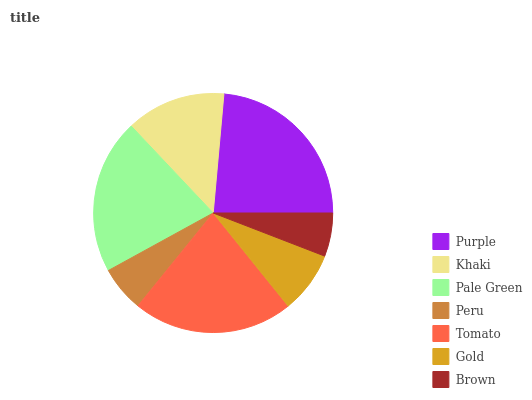Is Brown the minimum?
Answer yes or no. Yes. Is Purple the maximum?
Answer yes or no. Yes. Is Khaki the minimum?
Answer yes or no. No. Is Khaki the maximum?
Answer yes or no. No. Is Purple greater than Khaki?
Answer yes or no. Yes. Is Khaki less than Purple?
Answer yes or no. Yes. Is Khaki greater than Purple?
Answer yes or no. No. Is Purple less than Khaki?
Answer yes or no. No. Is Khaki the high median?
Answer yes or no. Yes. Is Khaki the low median?
Answer yes or no. Yes. Is Pale Green the high median?
Answer yes or no. No. Is Purple the low median?
Answer yes or no. No. 